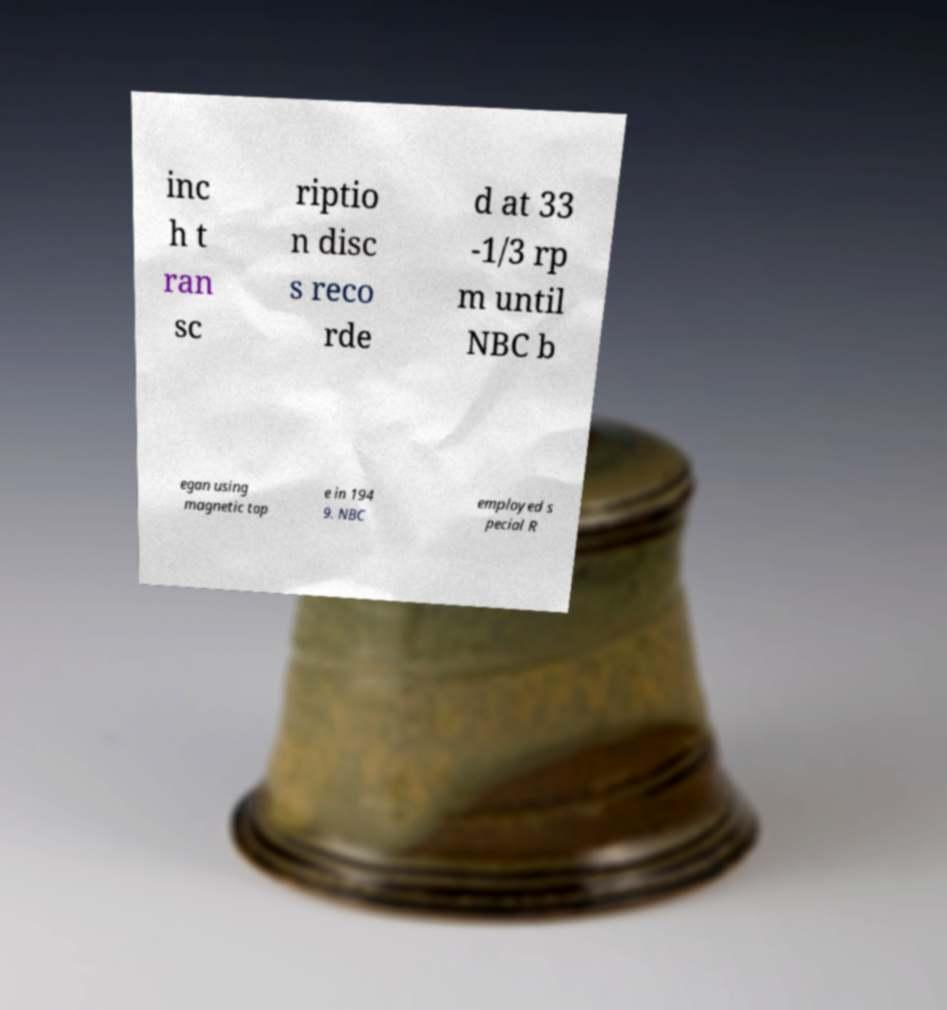Please identify and transcribe the text found in this image. inc h t ran sc riptio n disc s reco rde d at 33 -1/3 rp m until NBC b egan using magnetic tap e in 194 9. NBC employed s pecial R 